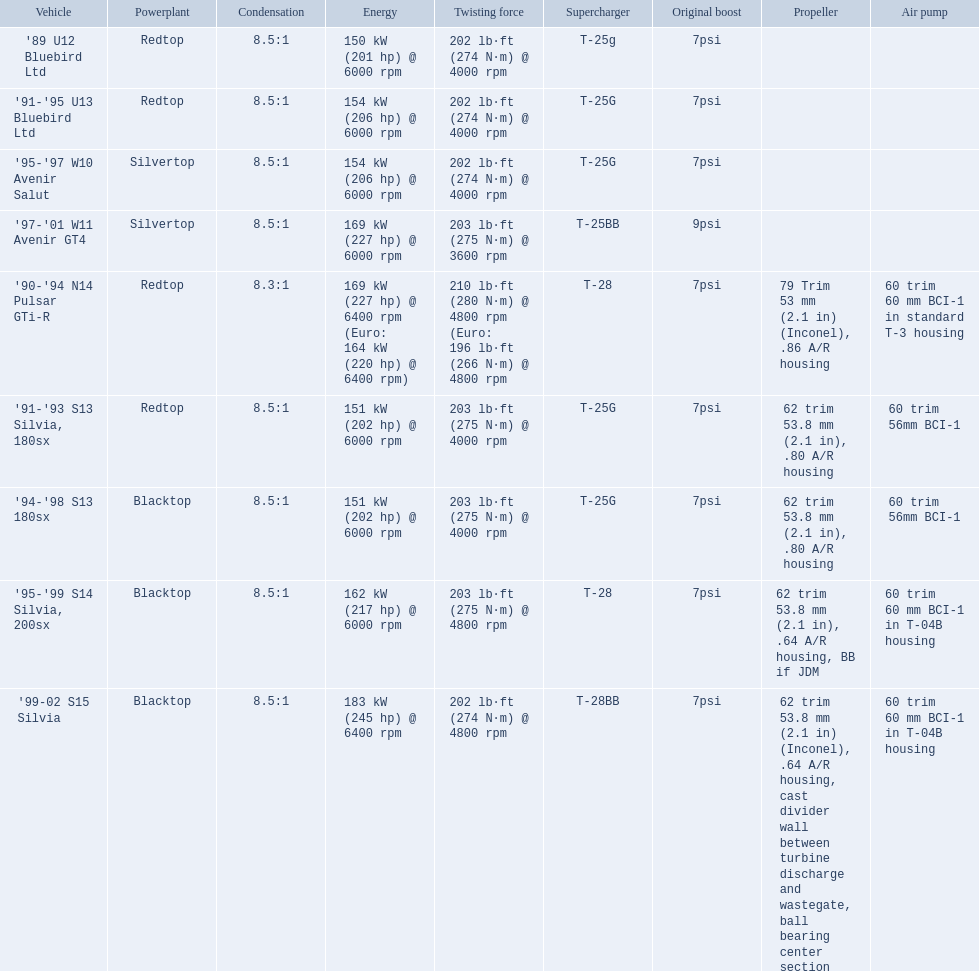What are the psi's? 7psi, 7psi, 7psi, 9psi, 7psi, 7psi, 7psi, 7psi, 7psi. What are the number(s) greater than 7? 9psi. Which car has that number? '97-'01 W11 Avenir GT4. What are all the cars? '89 U12 Bluebird Ltd, '91-'95 U13 Bluebird Ltd, '95-'97 W10 Avenir Salut, '97-'01 W11 Avenir GT4, '90-'94 N14 Pulsar GTi-R, '91-'93 S13 Silvia, 180sx, '94-'98 S13 180sx, '95-'99 S14 Silvia, 200sx, '99-02 S15 Silvia. What are their stock boosts? 7psi, 7psi, 7psi, 9psi, 7psi, 7psi, 7psi, 7psi, 7psi. And which car has the highest stock boost? '97-'01 W11 Avenir GT4. 